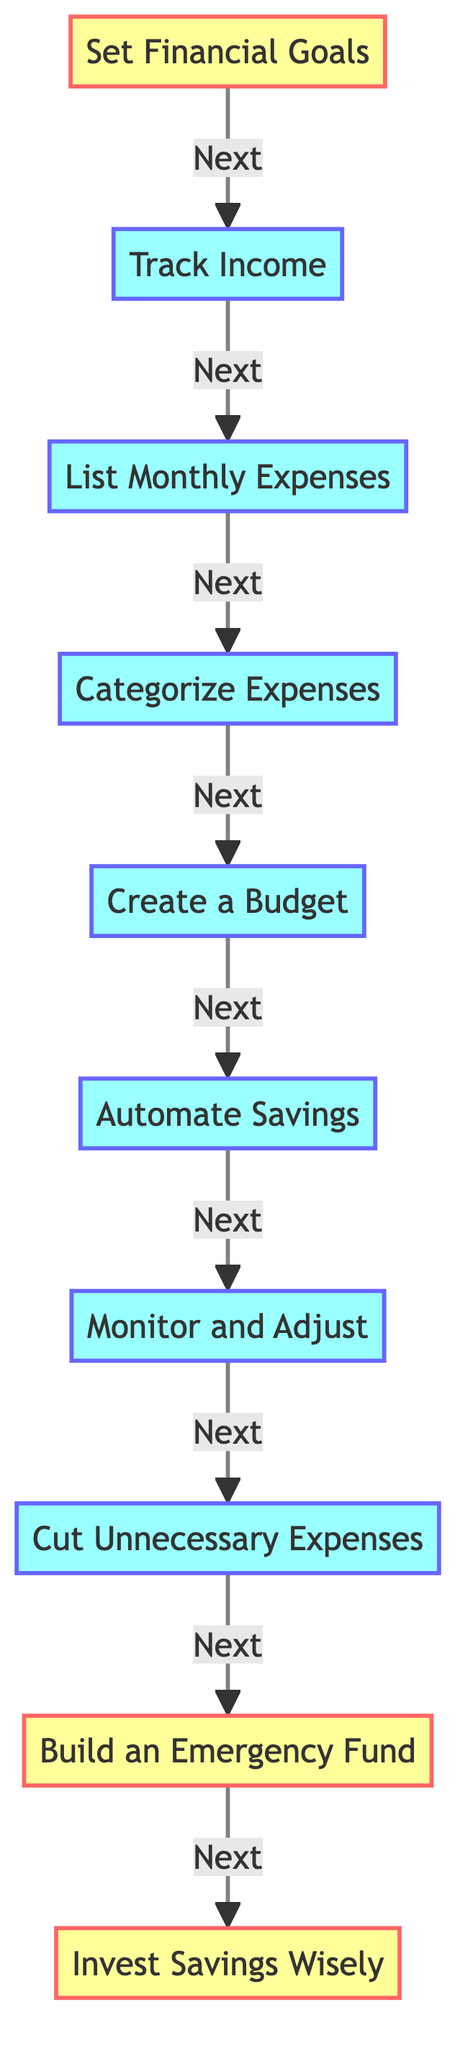What is the first step in the budgeting process? The first step in the flow chart is labeled "Set Financial Goals," indicating that this is where one begins the budgeting process.
Answer: Set Financial Goals How many total steps are there in this budgeting process? By counting the nodes in the diagram, we find that there are ten steps total represented from "Set Financial Goals" to "Invest Savings Wisely."
Answer: Ten Which step comes after "Monitor and Adjust"? Referring to the arrows pointing to the next nodes, the step that follows "Monitor and Adjust" is "Cut Unnecessary Expenses."
Answer: Cut Unnecessary Expenses What category does "Build an Emergency Fund" belong to? By examining the flow chart, we can see that "Build an Emergency Fund" is labeled as a "goal" step, denoting its importance in the overall budgeting process.
Answer: Goal Which steps are categorized as goals? Analyzing the flow chart, the steps labeled as goals are "Set Financial Goals," "Build an Emergency Fund," and "Invest Savings Wisely."
Answer: Set Financial Goals, Build an Emergency Fund, Invest Savings Wisely What does the step "Automate Savings" involve? In the diagram, "Automate Savings" is specifically described as setting up automatic transfers to a savings account, ensuring consistency in saving.
Answer: Setting up automatic transfers What is the purpose of "Categorize Expenses"? According to the description associated with this step, "Categorize Expenses" aims to separate expenses into 'Needs' and 'Wants' to prioritize spending.
Answer: Prioritize spending Describe the relationship between "Create a Budget" and "Track Income." The flow chart illustrates that "Track Income" precedes "Create a Budget," establishing that one must first identify income before budget allocation can happen.
Answer: "Track Income" precedes "Create a Budget" What should be done after identifying "Cut Unnecessary Expenses"? The next step indicated in the flow chart after "Cut Unnecessary Expenses" is "Build an Emergency Fund," suggesting that after making cuts, one should focus on saving for emergencies.
Answer: Build an Emergency Fund 